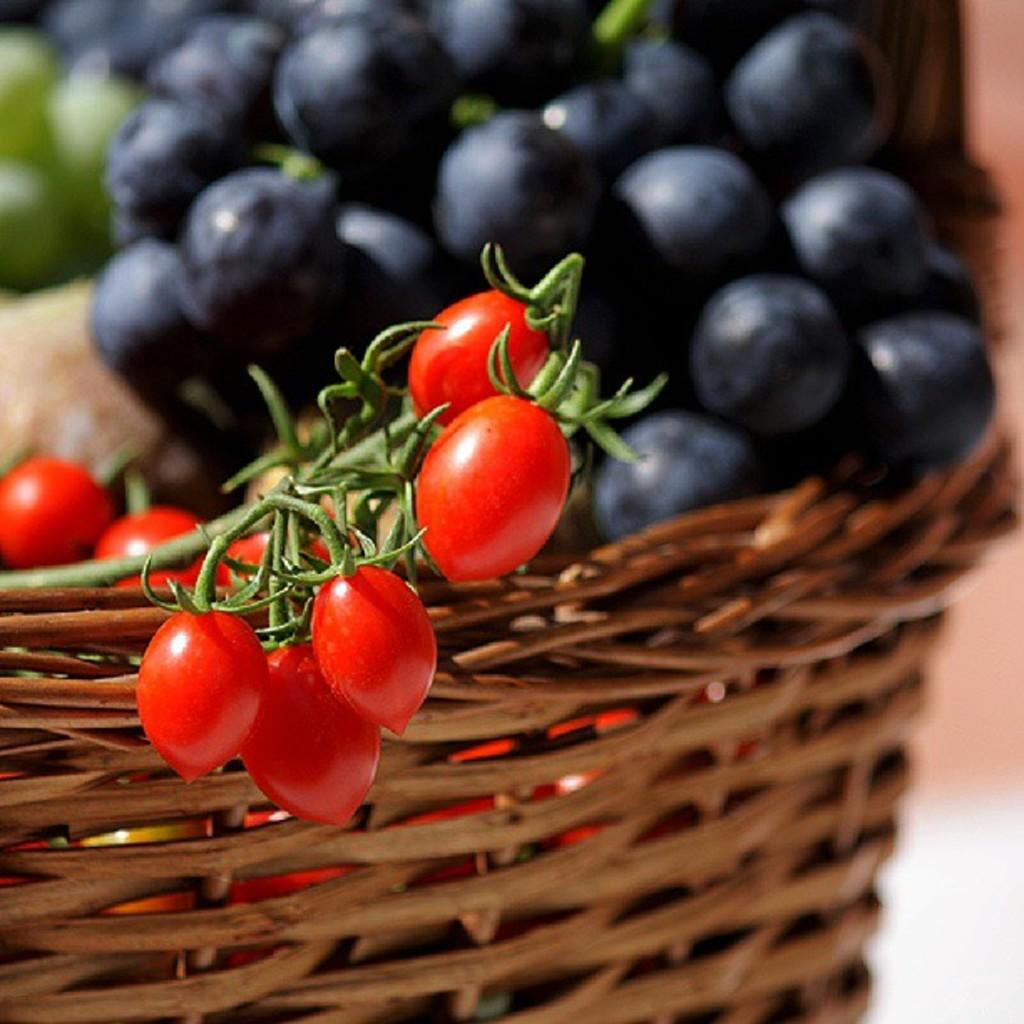What type of fruits can be seen in the image? There are cherries, blueberries, and grapes in the image. How are the fruits arranged or contained in the image? The fruits are in a basket. What songs are being played by the boat in the image? There is no boat or songs present in the image; it features a basket of fruits. 